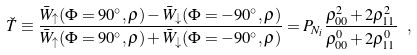<formula> <loc_0><loc_0><loc_500><loc_500>\check { T } \equiv \frac { \bar { W } _ { \uparrow } ( \Phi = 9 0 ^ { \circ } , \rho ) - \bar { W } _ { \downarrow } ( \Phi = - 9 0 ^ { \circ } , \rho ) } { \bar { W } _ { \uparrow } ( \Phi = 9 0 ^ { \circ } , \rho ) + \bar { W } _ { \downarrow } ( \Phi = - 9 0 ^ { \circ } , \rho ) } = P _ { N _ { i } } \frac { \rho ^ { 2 } _ { 0 0 } + 2 \rho ^ { 2 } _ { 1 1 } } { \rho ^ { 0 } _ { 0 0 } + 2 \rho ^ { 0 } _ { 1 1 } } \ ,</formula> 